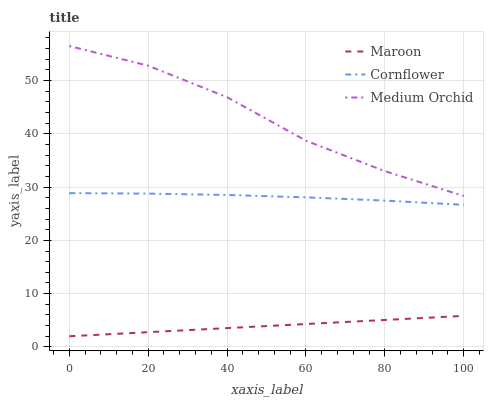Does Maroon have the minimum area under the curve?
Answer yes or no. Yes. Does Medium Orchid have the maximum area under the curve?
Answer yes or no. Yes. Does Medium Orchid have the minimum area under the curve?
Answer yes or no. No. Does Maroon have the maximum area under the curve?
Answer yes or no. No. Is Maroon the smoothest?
Answer yes or no. Yes. Is Medium Orchid the roughest?
Answer yes or no. Yes. Is Medium Orchid the smoothest?
Answer yes or no. No. Is Maroon the roughest?
Answer yes or no. No. Does Medium Orchid have the lowest value?
Answer yes or no. No. Does Maroon have the highest value?
Answer yes or no. No. Is Maroon less than Cornflower?
Answer yes or no. Yes. Is Medium Orchid greater than Maroon?
Answer yes or no. Yes. Does Maroon intersect Cornflower?
Answer yes or no. No. 